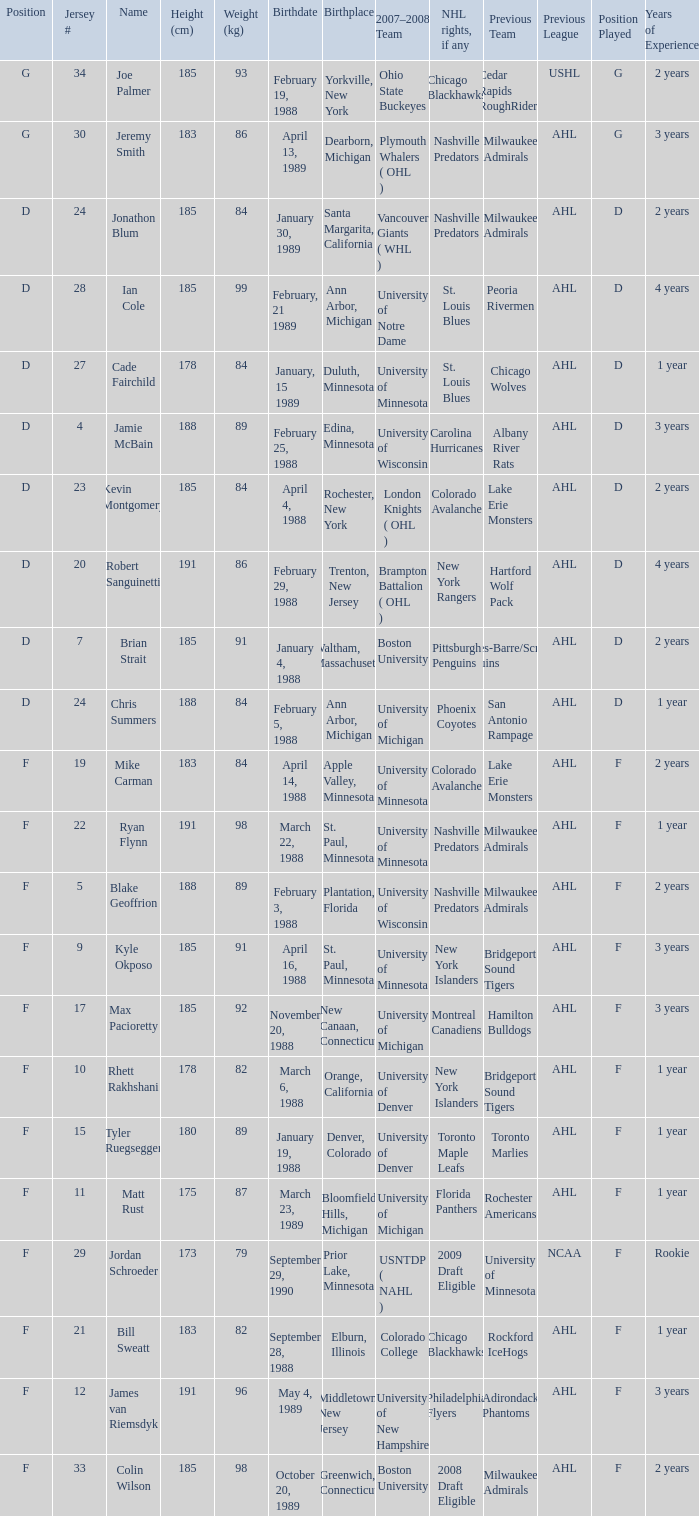Which Height (cm) has a Birthplace of new canaan, connecticut? 1.0. Parse the full table. {'header': ['Position', 'Jersey #', 'Name', 'Height (cm)', 'Weight (kg)', 'Birthdate', 'Birthplace', '2007–2008 Team', 'NHL rights, if any', 'Previous Team', 'Previous League', 'Position Played', 'Years of Experience'], 'rows': [['G', '34', 'Joe Palmer', '185', '93', 'February 19, 1988', 'Yorkville, New York', 'Ohio State Buckeyes', 'Chicago Blackhawks', 'Cedar Rapids RoughRiders', 'USHL', 'G', '2 years'], ['G', '30', 'Jeremy Smith', '183', '86', 'April 13, 1989', 'Dearborn, Michigan', 'Plymouth Whalers ( OHL )', 'Nashville Predators', 'Milwaukee Admirals', 'AHL', 'G', '3 years'], ['D', '24', 'Jonathon Blum', '185', '84', 'January 30, 1989', 'Santa Margarita, California', 'Vancouver Giants ( WHL )', 'Nashville Predators', 'Milwaukee Admirals', 'AHL', 'D', '2 years'], ['D', '28', 'Ian Cole', '185', '99', 'February, 21 1989', 'Ann Arbor, Michigan', 'University of Notre Dame', 'St. Louis Blues', 'Peoria Rivermen', 'AHL', 'D', '4 years'], ['D', '27', 'Cade Fairchild', '178', '84', 'January, 15 1989', 'Duluth, Minnesota', 'University of Minnesota', 'St. Louis Blues', 'Chicago Wolves', 'AHL', 'D', '1 year'], ['D', '4', 'Jamie McBain', '188', '89', 'February 25, 1988', 'Edina, Minnesota', 'University of Wisconsin', 'Carolina Hurricanes', 'Albany River Rats', 'AHL', 'D', '3 years'], ['D', '23', 'Kevin Montgomery', '185', '84', 'April 4, 1988', 'Rochester, New York', 'London Knights ( OHL )', 'Colorado Avalanche', 'Lake Erie Monsters', 'AHL', 'D', '2 years'], ['D', '20', 'Robert Sanguinetti', '191', '86', 'February 29, 1988', 'Trenton, New Jersey', 'Brampton Battalion ( OHL )', 'New York Rangers', 'Hartford Wolf Pack', 'AHL', 'D', '4 years'], ['D', '7', 'Brian Strait', '185', '91', 'January 4, 1988', 'Waltham, Massachusetts', 'Boston University', 'Pittsburgh Penguins', 'Wilkes-Barre/Scranton Penguins', 'AHL', 'D', '2 years'], ['D', '24', 'Chris Summers', '188', '84', 'February 5, 1988', 'Ann Arbor, Michigan', 'University of Michigan', 'Phoenix Coyotes', 'San Antonio Rampage', 'AHL', 'D', '1 year'], ['F', '19', 'Mike Carman', '183', '84', 'April 14, 1988', 'Apple Valley, Minnesota', 'University of Minnesota', 'Colorado Avalanche', 'Lake Erie Monsters', 'AHL', 'F', '2 years'], ['F', '22', 'Ryan Flynn', '191', '98', 'March 22, 1988', 'St. Paul, Minnesota', 'University of Minnesota', 'Nashville Predators', 'Milwaukee Admirals', 'AHL', 'F', '1 year'], ['F', '5', 'Blake Geoffrion', '188', '89', 'February 3, 1988', 'Plantation, Florida', 'University of Wisconsin', 'Nashville Predators', 'Milwaukee Admirals', 'AHL', 'F', '2 years'], ['F', '9', 'Kyle Okposo', '185', '91', 'April 16, 1988', 'St. Paul, Minnesota', 'University of Minnesota', 'New York Islanders', 'Bridgeport Sound Tigers', 'AHL', 'F', '3 years'], ['F', '17', 'Max Pacioretty', '185', '92', 'November 20, 1988', 'New Canaan, Connecticut', 'University of Michigan', 'Montreal Canadiens', 'Hamilton Bulldogs', 'AHL', 'F', '3 years'], ['F', '10', 'Rhett Rakhshani', '178', '82', 'March 6, 1988', 'Orange, California', 'University of Denver', 'New York Islanders', 'Bridgeport Sound Tigers', 'AHL', 'F', '1 year'], ['F', '15', 'Tyler Ruegsegger', '180', '89', 'January 19, 1988', 'Denver, Colorado', 'University of Denver', 'Toronto Maple Leafs', 'Toronto Marlies', 'AHL', 'F', '1 year'], ['F', '11', 'Matt Rust', '175', '87', 'March 23, 1989', 'Bloomfield Hills, Michigan', 'University of Michigan', 'Florida Panthers', 'Rochester Americans', 'AHL', 'F', '1 year'], ['F', '29', 'Jordan Schroeder', '173', '79', 'September 29, 1990', 'Prior Lake, Minnesota', 'USNTDP ( NAHL )', '2009 Draft Eligible', 'University of Minnesota', 'NCAA', 'F', 'Rookie'], ['F', '21', 'Bill Sweatt', '183', '82', 'September 28, 1988', 'Elburn, Illinois', 'Colorado College', 'Chicago Blackhawks', 'Rockford IceHogs', 'AHL', 'F', '1 year'], ['F', '12', 'James van Riemsdyk', '191', '96', 'May 4, 1989', 'Middletown, New Jersey', 'University of New Hampshire', 'Philadelphia Flyers', 'Adirondack Phantoms', 'AHL', 'F', '3 years'], ['F', '33', 'Colin Wilson', '185', '98', 'October 20, 1989', 'Greenwich, Connecticut', 'Boston University', '2008 Draft Eligible', 'Milwaukee Admirals', 'AHL', 'F', '2 years']]} 